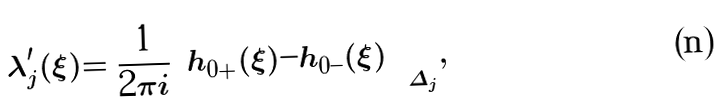Convert formula to latex. <formula><loc_0><loc_0><loc_500><loc_500>\lambda _ { j } ^ { \prime } ( \xi ) = \frac { 1 } { 2 \pi i } \Big ( h _ { 0 + } ( \xi ) - h _ { 0 - } ( \xi ) \Big ) \Big | _ { \Delta _ { j } } ,</formula> 